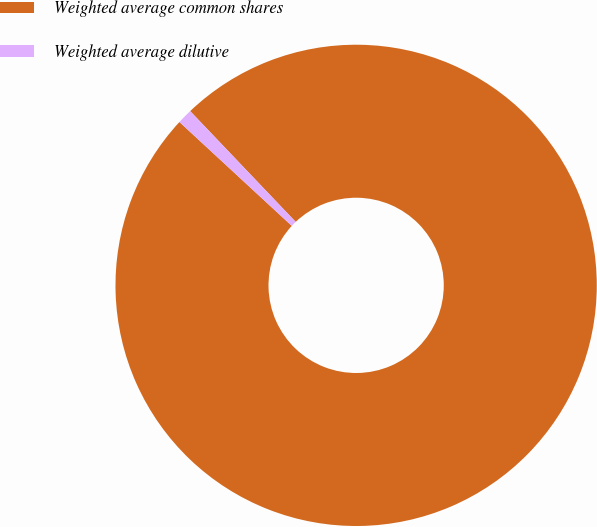<chart> <loc_0><loc_0><loc_500><loc_500><pie_chart><fcel>Weighted average common shares<fcel>Weighted average dilutive<nl><fcel>98.99%<fcel>1.01%<nl></chart> 